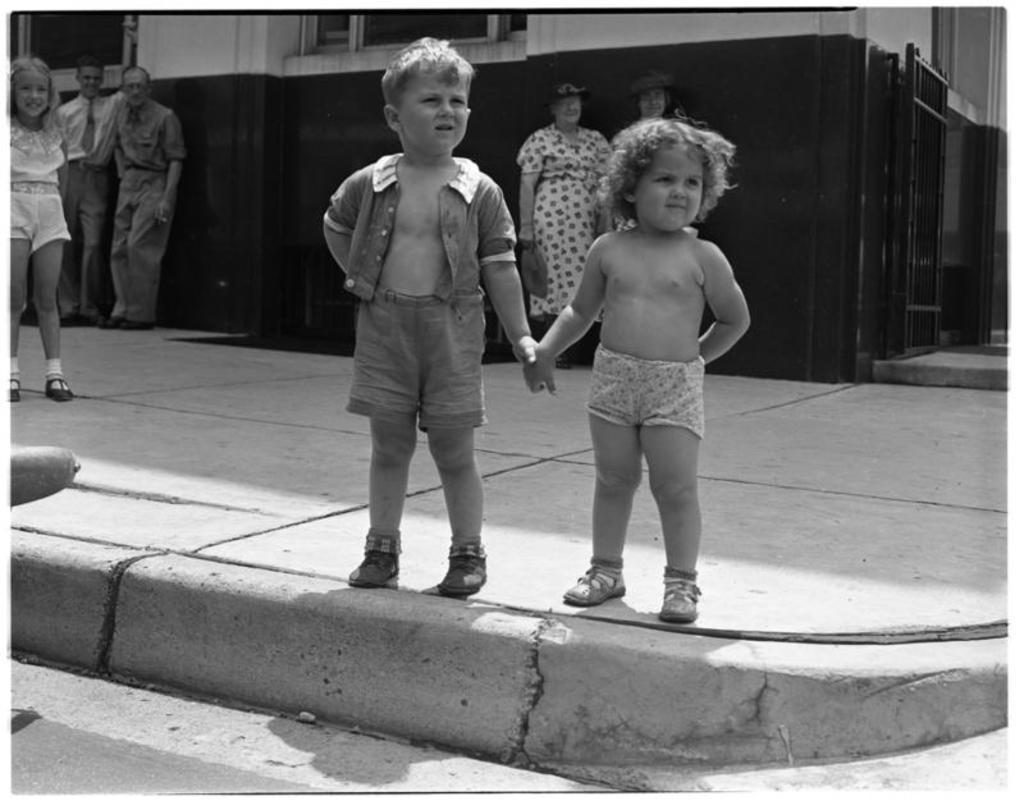Who are the two people in the image? There is a girl and a boy in the image. What are the girl and boy doing in the image? The girl and boy are holding hands. Where are the girl and boy standing in the image? They are standing on a path. Are there any other people visible in the image? Yes, there are other people visible on the path. What can be seen in the background of the image? There is a building and a gate in the background of the image. What type of ice is being used to build the government building in the image? There is no ice or government building present in the image. 